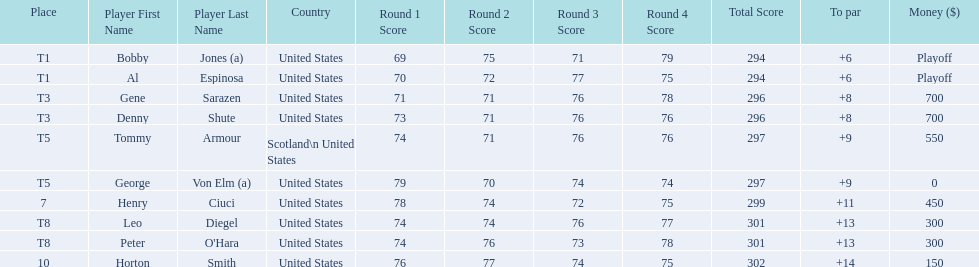How many players represented scotland? 1. 